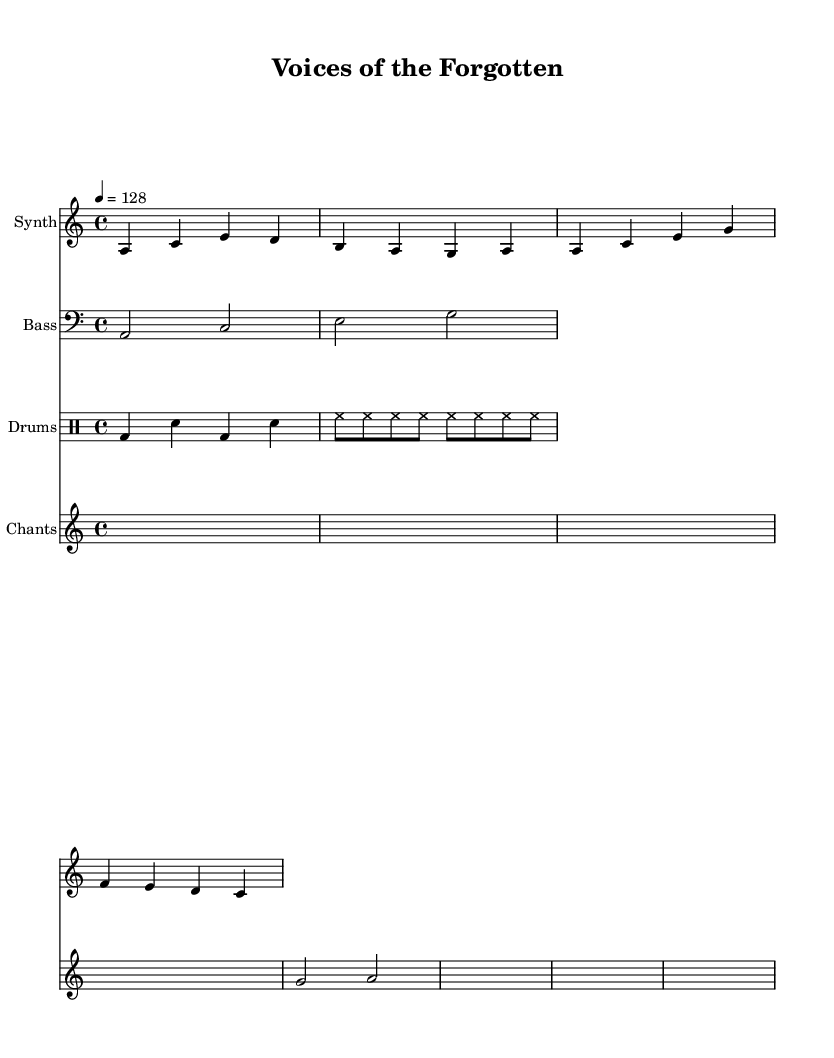What is the key signature of this music? The key signature is indicated by the placement of sharps or flats at the beginning of the staff. In this piece, ‘a’ is noted but no sharps or flats are present, which means it follows the A minor scale containing no accidentals.
Answer: A minor What is the time signature of this music? The time signature is shown at the beginning of the staff, represented by the numbers above the staff. Here, it reads 4/4, indicating four beats per measure with a quarter note receiving one beat.
Answer: 4/4 What is the tempo marking of this piece? The tempo marking is located above the staff, showing the speed of the piece. In this case, it indicates "4 = 128," meaning there are 128 beats per minute.
Answer: 128 How many measures does the synth melody have? To count the measures, we look at the visual divisions in the synth melody staff within the provided sequence. The melody is divided into four measures.
Answer: 4 What unique element does this composition include that connects to indigenous culture? While examining the structure of the score, we see a separate staff labeled "Chants," which shows that indigenous samples are intentionally incorporated into the composition, highlighting cultural representation.
Answer: Chants Which instrument plays the bass part? The score indicates the instrument used for the bass part through the label on the staff, denoting it as "Bass." This identifies the section dedicated to the low frequency or bass sound.
Answer: Bass What is the rhythmic pattern of the drums? The rhythm can be determined by analyzing the drum staff, where the pattern consists of bass drum hits followed by snare hits and cymbal hits, portrayed via specific symbols in drumming notation.
Answer: Bass and snare 